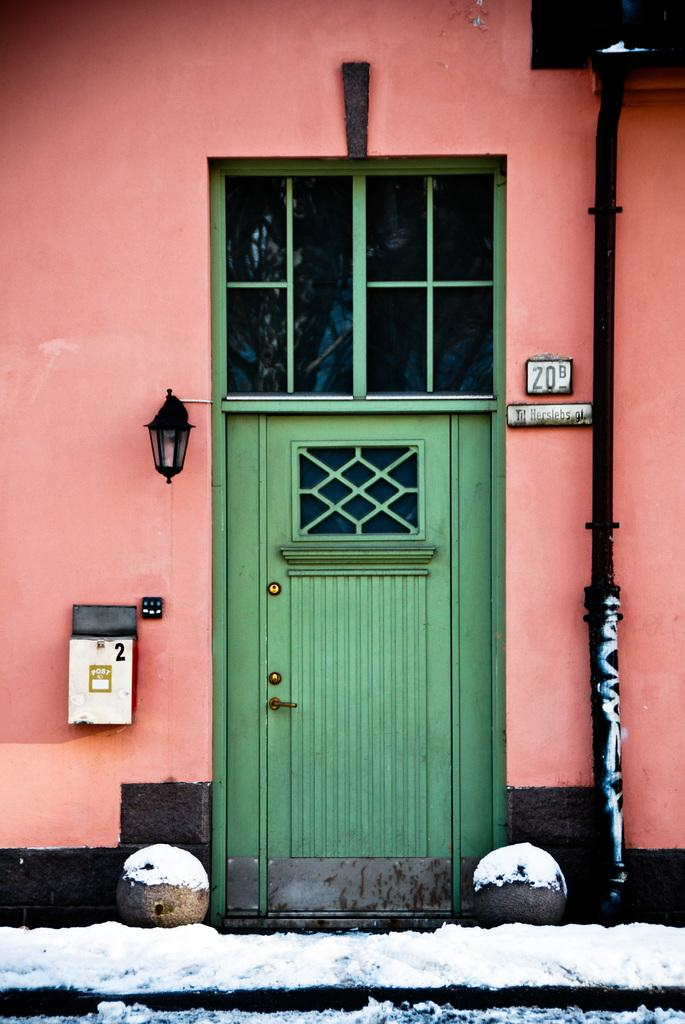What color is the door in the image? The door in the image is green. What color is the wall in the image? The wall in the image is pink. What is covering the ground in front of the wall? There is snow in front of the wall. What type of object is black and visible in the image? There is a black pipe in the image. Who is the owner of the song playing in the image? There is no song playing in the image, so it is not possible to determine the owner. What type of wire can be seen connected to the black pipe in the image? There is no wire connected to the black pipe in the image. 